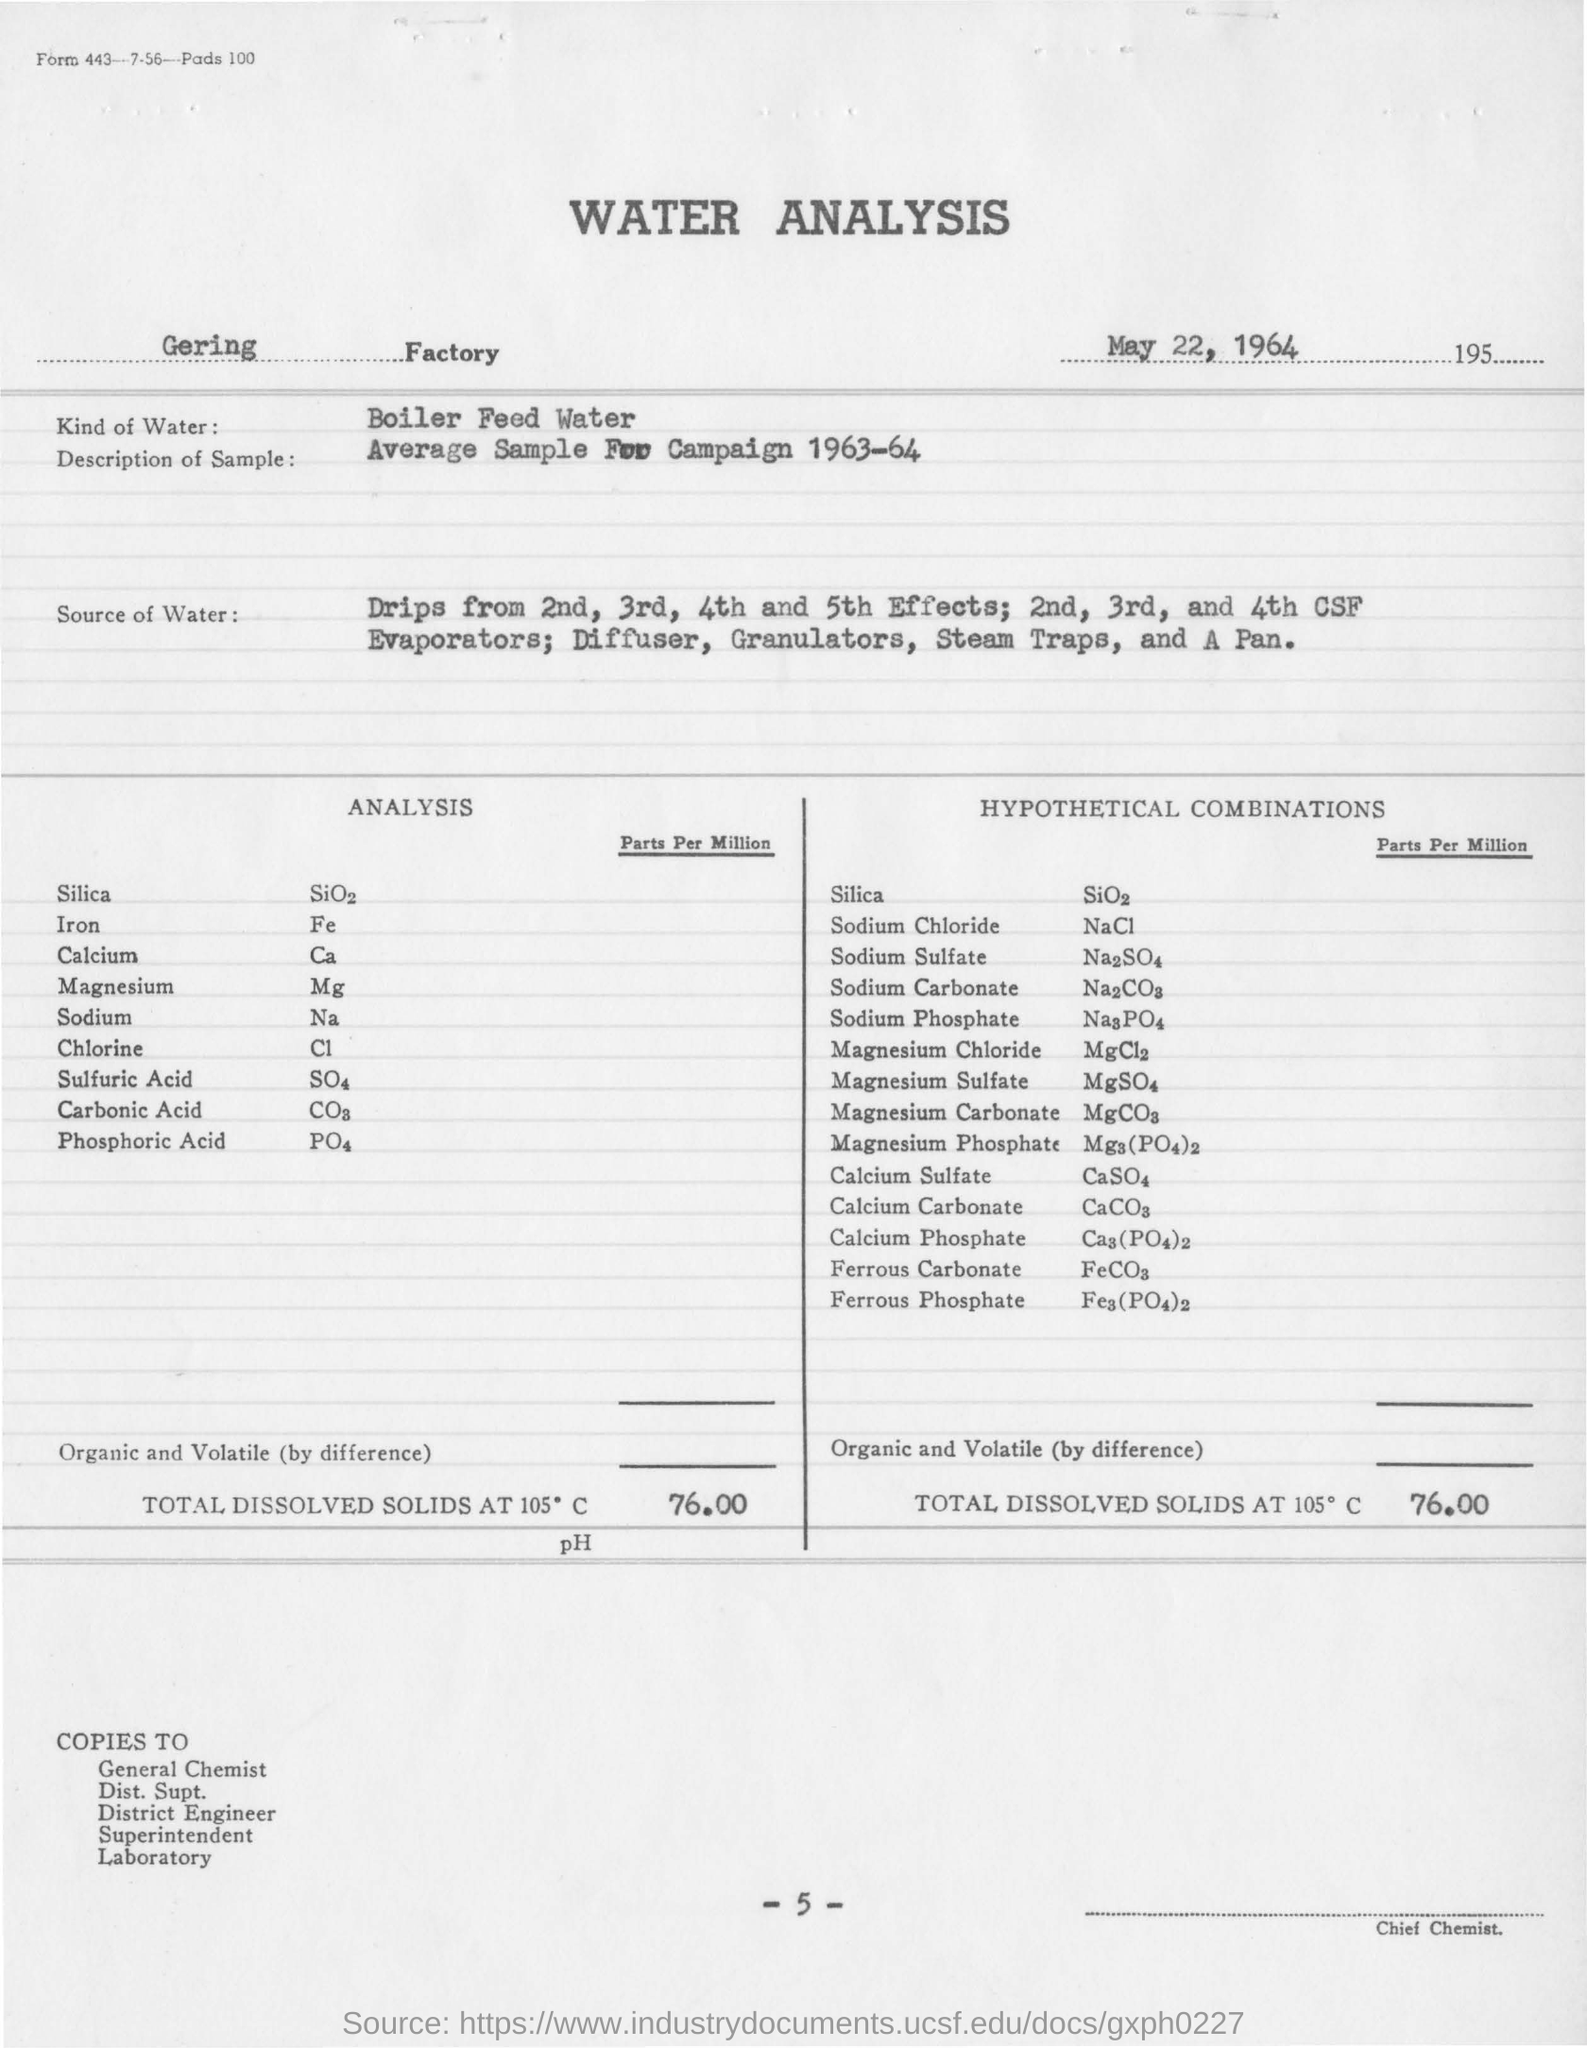What date was this water analysis report issued? The water analysis report was issued on May 22, 1964, as indicated at the top of the document. 